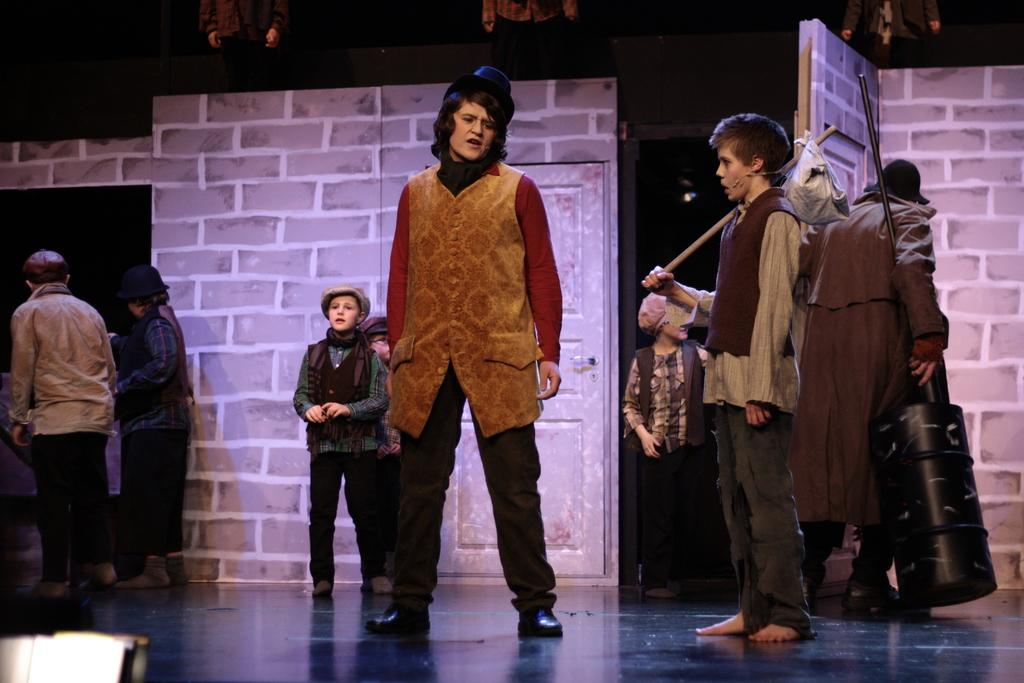What is happening on the stage in the image? There are groups of people standing on the stage. What are two persons doing in the image? Two persons are holding two objects. How many persons are at the top of the image? There are three persons at the top of the image. What is the color of the background in the image? The background of the image is dark. What type of birds can be seen flying in the image? There are no birds present in the image; it features groups of people standing on a stage. What is the friction between the two objects being held by the two persons in the image? The provided facts do not mention any friction between the objects being held by the two persons, nor is there any information about the objects themselves. 